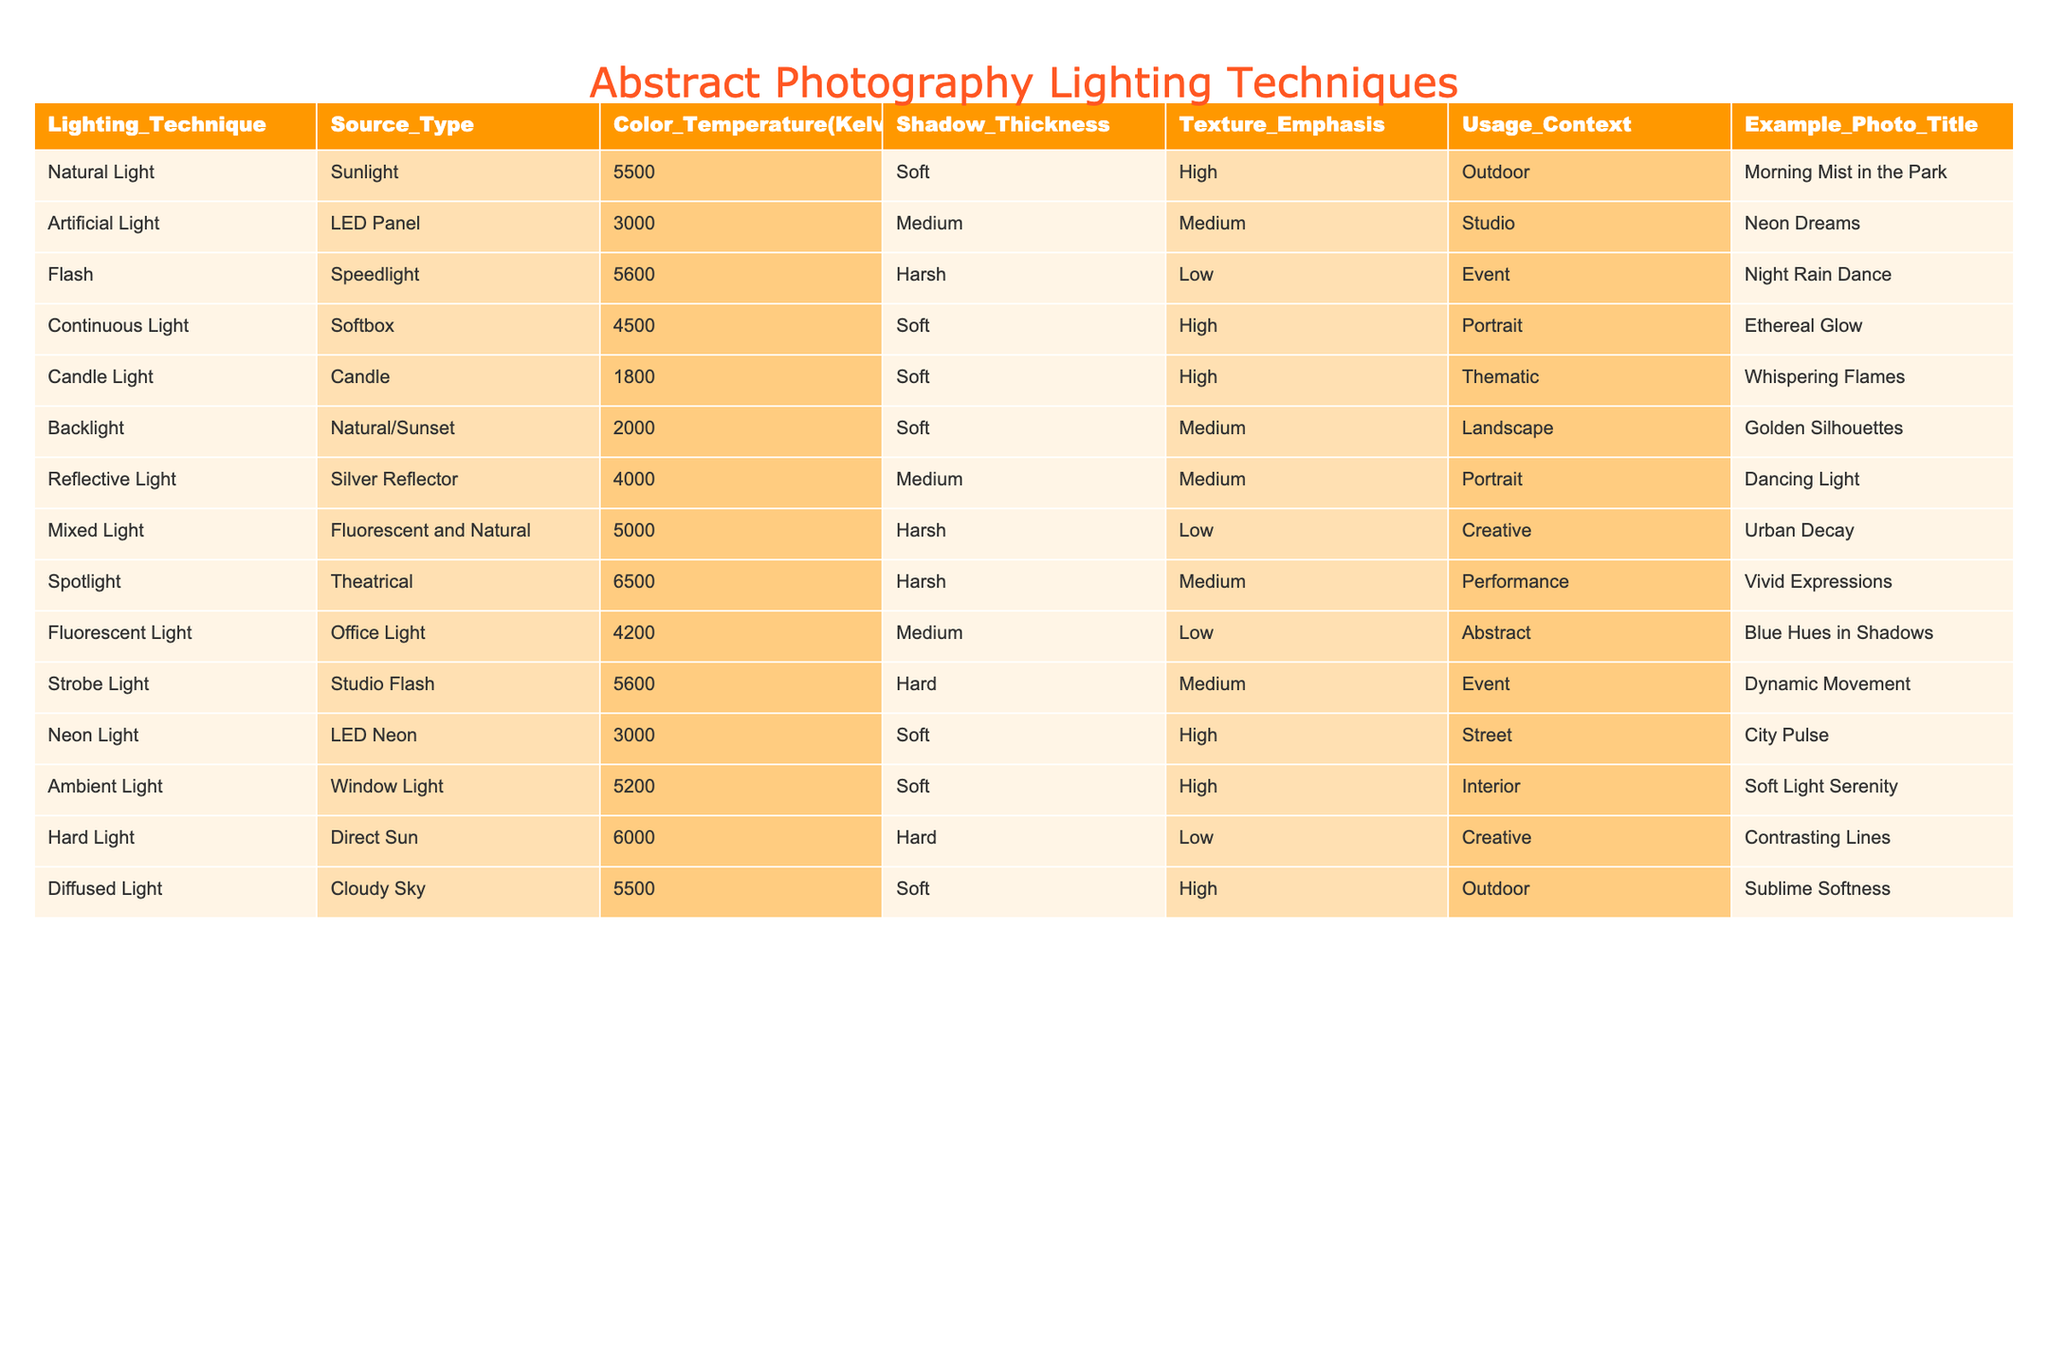What lighting technique has the highest color temperature? The table lists color temperatures for each lighting technique, and the highest value is 6500 Kelvin, which corresponds to the Spotlight technique.
Answer: Spotlight How many lighting techniques use soft shadow thickness? By looking at the table, the techniques with soft shadow thickness are Natural Light, Continuous Light, Candle Light, Backlight, Neon Light, Ambient Light, and Diffused Light, totaling 7 techniques.
Answer: 7 Is there any lighting technique that emphasizes texture low? The techniques that have low texture emphasis are Flash, Mixed Light, Fluorescent Light, and Hard Light, indicating that there are indeed four techniques with low emphasis on texture.
Answer: Yes What is the average color temperature of all lighting techniques listed? The color temperatures are 5500, 3000, 5600, 4500, 1800, 2000, 4000, 5000, 6500, 4200, 5600, 3000, 5200, 6000, and 5500 Kelvin. Summing these gives a total of 42,700 Kelvin, and dividing by 14 (the number of techniques) results in an average color temperature of 3,050 Kelvin.
Answer: 4,050 Kelvin Which lighting techniques are used in both outdoor and indoor contexts? The table indicates that Natural Light (outdoor) and Softbox (indoor) have different contexts, but by looking through the context column, only the Ambient Light technique is relevant for indoor usage while being soft as well but appears throughout different contexts. So it’s confirmed indoor/ outdoor encompasses at least two that overlap in outdoor.
Answer: Ambient Light What is the difference between the highest and lowest color temperatures? The highest color temperature is 6500 Kelvin from the Spotlight technique, and the lowest is 1800 Kelvin from Candle Light. The difference is calculated as 6500 - 1800 = 4700 Kelvin.
Answer: 4700 Kelvin How many techniques emphasize texture as high? By checking the table, the techniques emphasizing high texture are Natural Light, Continuous Light, Candle Light, Neon Light, and Ambient Light, resulting in a total of 5 techniques.
Answer: 5 Do any lighting techniques use both natural and artificial sources? The Mixed Light technique combines elements from both natural and artificial sources, such as fluorescent and natural light and is indicated in the table.
Answer: Yes 